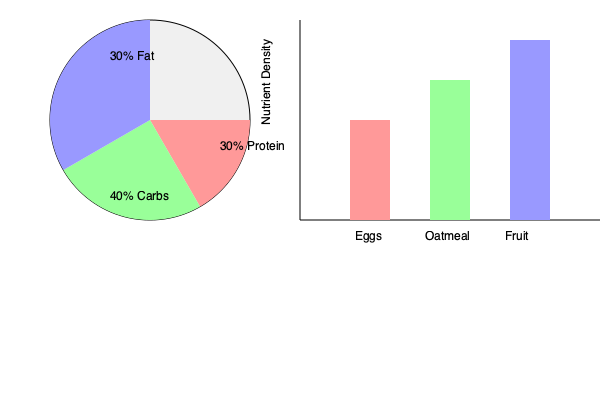As a B&B owner, you want to optimize your breakfast menu for variety and nutrition. The pie chart shows the recommended macronutrient balance, while the bar graph displays the nutrient density of three breakfast items. Which combination of two items would best help achieve the recommended macronutrient balance while maximizing nutrient density? To answer this question, we need to analyze both the pie chart and the bar graph:

1. The pie chart shows the recommended macronutrient balance:
   - 30% Protein
   - 40% Carbohydrates
   - 30% Fat

2. The bar graph shows the nutrient density of three breakfast items:
   - Eggs: Moderate nutrient density
   - Oatmeal: High nutrient density
   - Fruit: Highest nutrient density

3. We need to consider the macronutrient composition of each item:
   - Eggs are high in protein and fat, low in carbohydrates
   - Oatmeal is high in carbohydrates, moderate in protein, low in fat
   - Fruit is high in carbohydrates, low in protein and fat

4. To achieve the recommended balance:
   - We need a protein source (eggs)
   - We need a carbohydrate source (oatmeal or fruit)

5. Comparing nutrient density:
   - Fruit has the highest nutrient density
   - Oatmeal has the second-highest nutrient density

6. The best combination would be:
   - Eggs: Provide protein and fat
   - Fruit: Provide carbohydrates and highest nutrient density

This combination helps achieve the macronutrient balance while maximizing nutrient density. The eggs contribute to the protein and fat requirements, while the fruit provides carbohydrates and essential micronutrients.
Answer: Eggs and fruit 